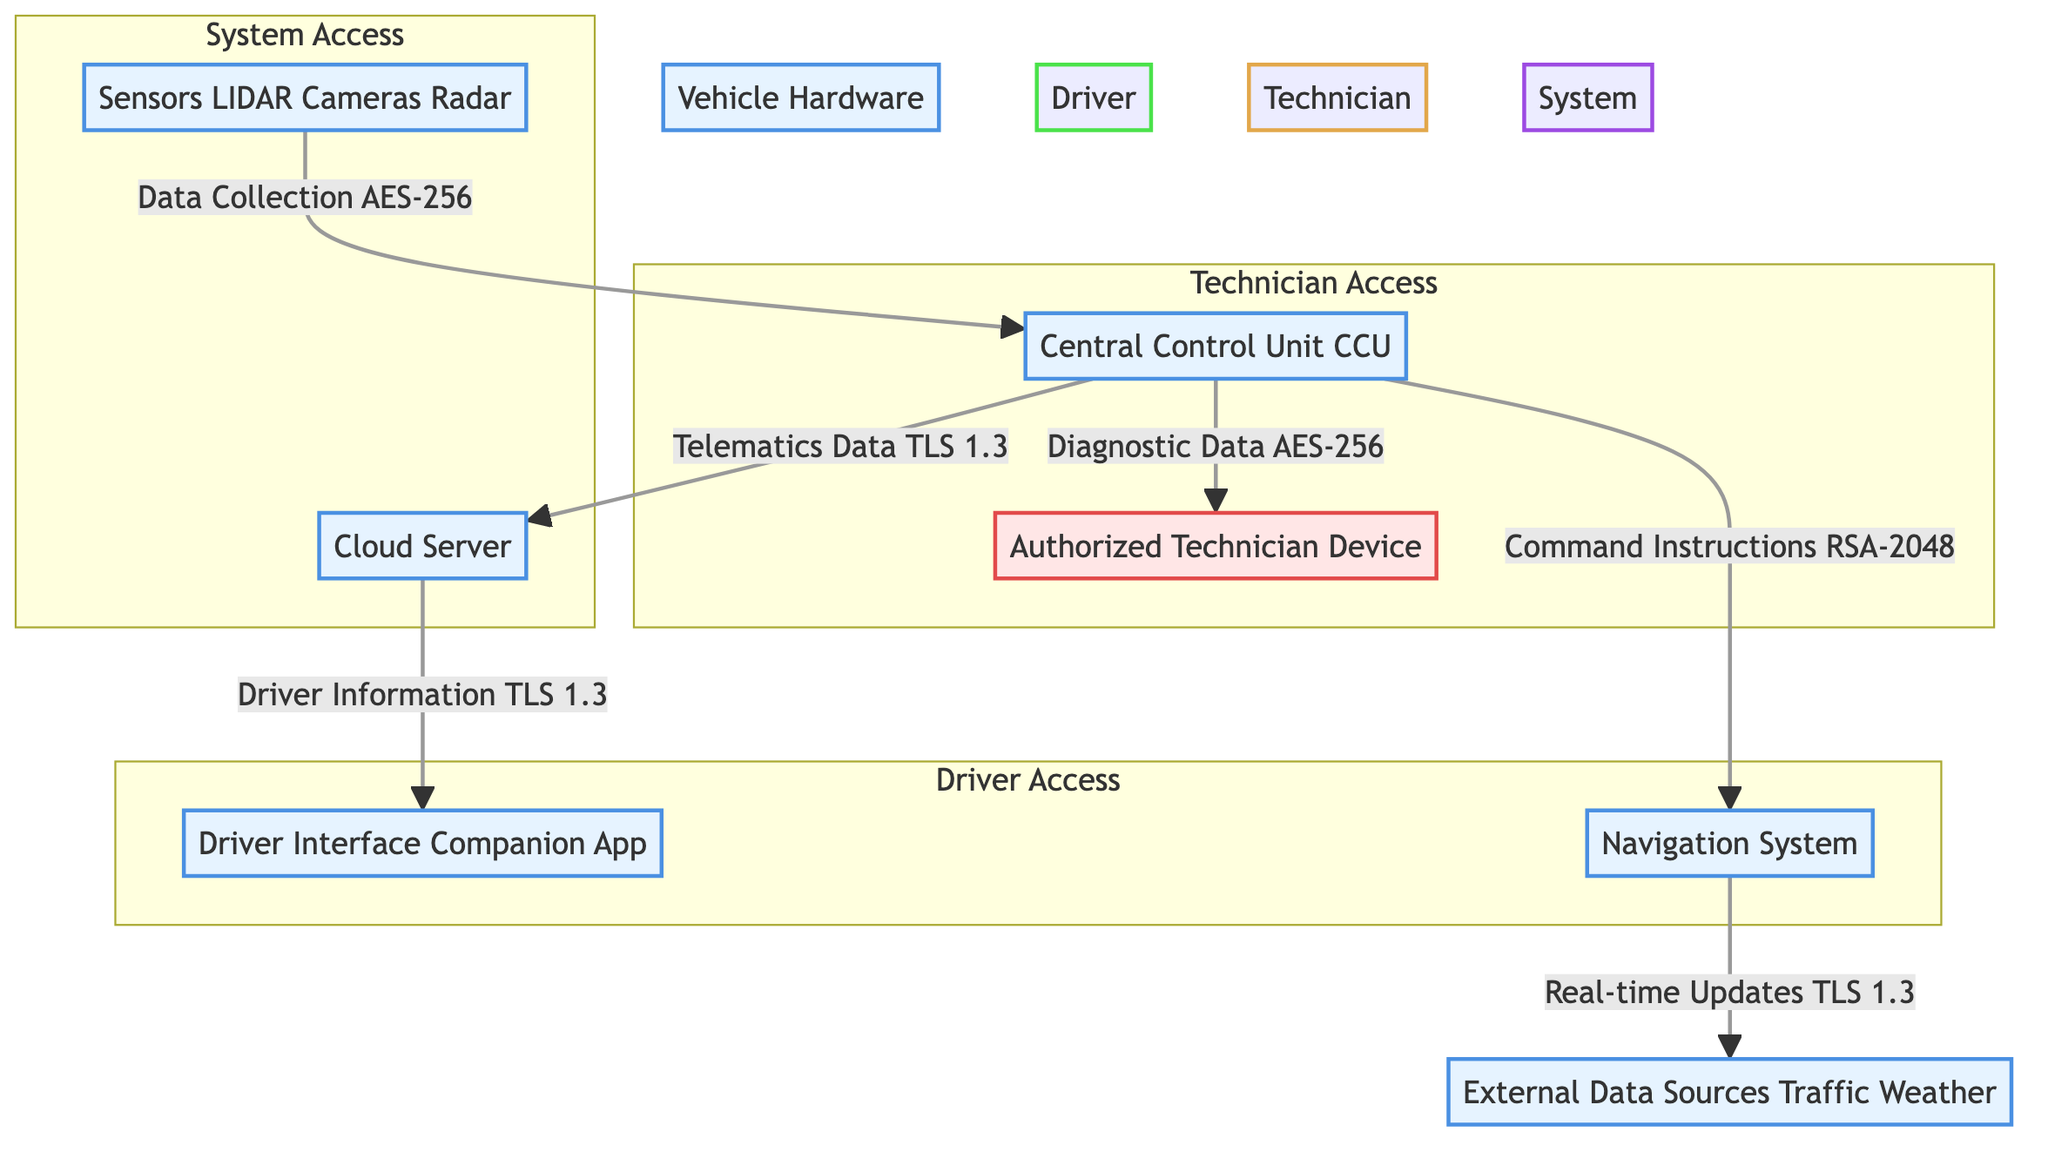What are the roles with full access in the system? The diagram specifies that the role with full access belongs to the system, which includes nodes like sensors, central control unit, navigation system, and cloud server.
Answer: System How many edges connect the navigation system? The navigation system has two edges connecting it: one to the external data sources and one to the central control unit, therefore there are two edges connecting to this node.
Answer: 2 What is the encryption method used for telematics data? The encryption method for telematics data transferred from the central control unit to the cloud server is specified as TLS 1.3 in the diagram.
Answer: TLS 1.3 Which component retrieves real-time updates from external data sources? The navigation system retrieves real-time updates from external data sources, as indicated by the directed edge connecting these two components in the diagram.
Answer: Navigation System What is the access level of the technician role? The diagram indicates that the technician role has Read/Write access, allowing them to move data in and out of the authorized technician device and central control unit.
Answer: Read/Write How is diagnostic data transferred to the authorized technician device? Diagnostic data is transferred to the authorized technician device through the OBD-II access point, and it is encrypted using AES-256, as shown in the diagram's specific edge.
Answer: OBD-II From which access point does the central control unit send telematics data? The central control unit sends telematics data through the 4G/5G access point to the cloud server, as depicted by the connecting edge in the diagram.
Answer: 4G/5G Which two nodes are included in the driver access subgraph? The driver access subgraph consists of the driver interface companion app and the navigation system, represented within the drawn boundary in the diagram.
Answer: Driver Interface Companion App, Navigation System What type of data does the sensors node send to the central control unit? The sensors node sends data collection to the central control unit, as identified by the directed edge from the sensors to the central control unit labeled Data Collection.
Answer: Data Collection 